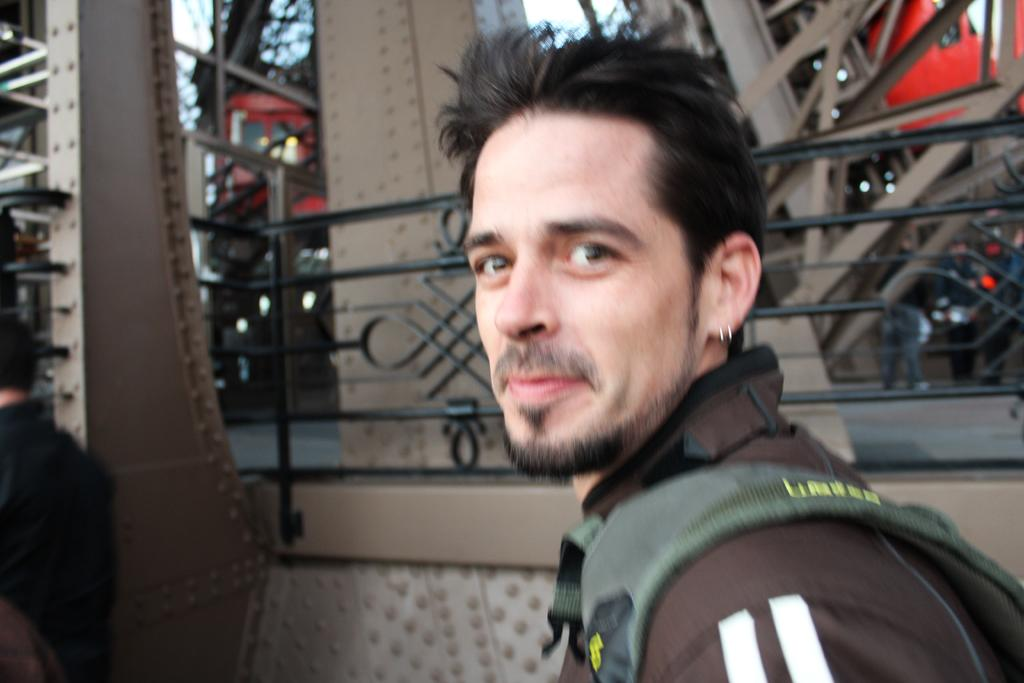How many people are in the image? There are two people in the image. What is one person holding in the image? One person is holding a bag. What can be seen in the background of the image? There is railing visible in the background, along with a few objects and the sky. What type of sense can be seen in the image? There is no sense visible in the image; it is a photograph and does not depict any sensory organs or experiences. 